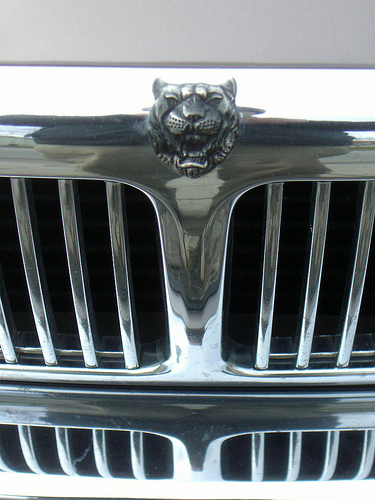<image>
Can you confirm if the tiger is behind the car? No. The tiger is not behind the car. From this viewpoint, the tiger appears to be positioned elsewhere in the scene. 